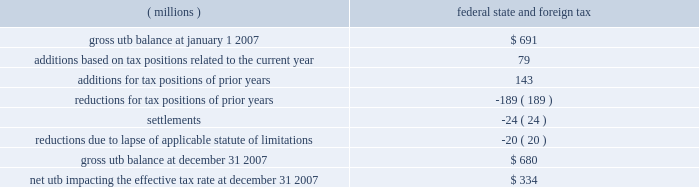The company files income tax returns in the u.s .
Federal jurisdiction , and various states and foreign jurisdictions .
With few exceptions , the company is no longer subject to u.s .
Federal , state and local , or non-u.s .
Income tax examinations by tax authorities for years before 1999 .
It is anticipated that its examination for the company 2019s u.s .
Income tax returns for the years 2002 through 2004 will be completed by the end of first quarter 2008 .
As of december 31 , 2007 , the irs has proposed adjustments to the company 2019s tax positions for which the company is fully reserved .
Payments relating to any proposed assessments arising from the 2002 through 2004 audit may not be made until a final agreement is reached between the company and the irs on such assessments or upon a final resolution resulting from the administrative appeals process or judicial action .
In addition to the u.s .
Federal examination , there is also limited audit activity in several u.s .
State and foreign jurisdictions .
Currently , the company expects the liability for unrecognized tax benefits to change by an insignificant amount during the next 12 months .
The company adopted the provisions of fasb interpretation no .
48 , 201caccounting for uncertainty in income taxes , 201d on january 1 , 2007 .
As a result of the implementation of interpretation 48 , the company recognized an immaterial increase in the liability for unrecognized tax benefits , which was accounted for as a reduction to the january 1 , 2007 , balance of retained earnings .
A reconciliation of the beginning and ending amount of gross unrecognized tax benefits ( 201cutb 201d ) is as follows : ( millions ) federal , state , and foreign tax .
The total amount of unrecognized tax benefits that , if recognized , would affect the effective tax rate as of january 1 , 2007 and december 31 , 2007 , respectively , are $ 261 million and $ 334 million .
The ending net utb results from adjusting the gross balance at december 31 , 2007 for items such as federal , state , and non-u.s .
Deferred items , interest and penalties , and deductible taxes .
The net utb is included as components of accrued income taxes and other liabilities within the consolidated balance sheet .
The company recognizes interest and penalties accrued related to unrecognized tax benefits in tax expense .
At january 1 , 2007 and december 31 , 2007 , accrued interest and penalties on a gross basis were $ 65 million and $ 69 million , respectively .
Included in these interest and penalty amounts is interest and penalties related to tax positions for which the ultimate deductibility is highly certain but for which there is uncertainty about the timing of such deductibility .
Because of the impact of deferred tax accounting , other than interest and penalties , the disallowance of the shorter deductibility period would not affect the annual effective tax rate but would accelerate the payment of cash to the taxing authority to an earlier period .
In 2007 , the company completed the preparation and filing of its 2006 u.s .
Federal and state income tax returns , which did not result in any material changes to the company 2019s financial position .
In 2006 , an audit of the company 2019s u.s .
Tax returns for years through 2001 was completed .
The company and the internal revenue service reached a final settlement for these years , including an agreement on the amount of a refund claim to be filed by the company .
The company also substantially resolved audits in certain european countries .
In addition , the company completed the preparation and filing of its 2005 u.s .
Federal income tax return and the corresponding 2005 state income tax returns .
The adjustments from amounts previously estimated in the u.s .
Federal and state income tax returns ( both positive and negative ) included lower u.s .
Taxes on dividends received from the company's foreign subsidiaries .
The company also made quarterly adjustments ( both positive and negative ) to its reserves for tax contingencies .
Considering the developments noted above and other factors , including the impact on open audit years of the recent resolution of issues in various audits , these reassessments resulted in a reduction of the reserves in 2006 by $ 149 million , inclusive of the expected amount of certain refund claims .
In 2005 , the company announced its intent to reinvest $ 1.7 billion of foreign earnings in the united states pursuant to the provisions of the american jobs creation act of 2004 .
This act provided the company the opportunity to tax- .
In 2007 what was the ratio of the beginning gross unrecognized tax benefits to the ending balance? 
Rationale: every $ 2.1 in the gross unrecognized tax benefits led to a $ 1 in the net unrecognized tax benefits
Computations: (691 / 334)
Answer: 2.06886. 